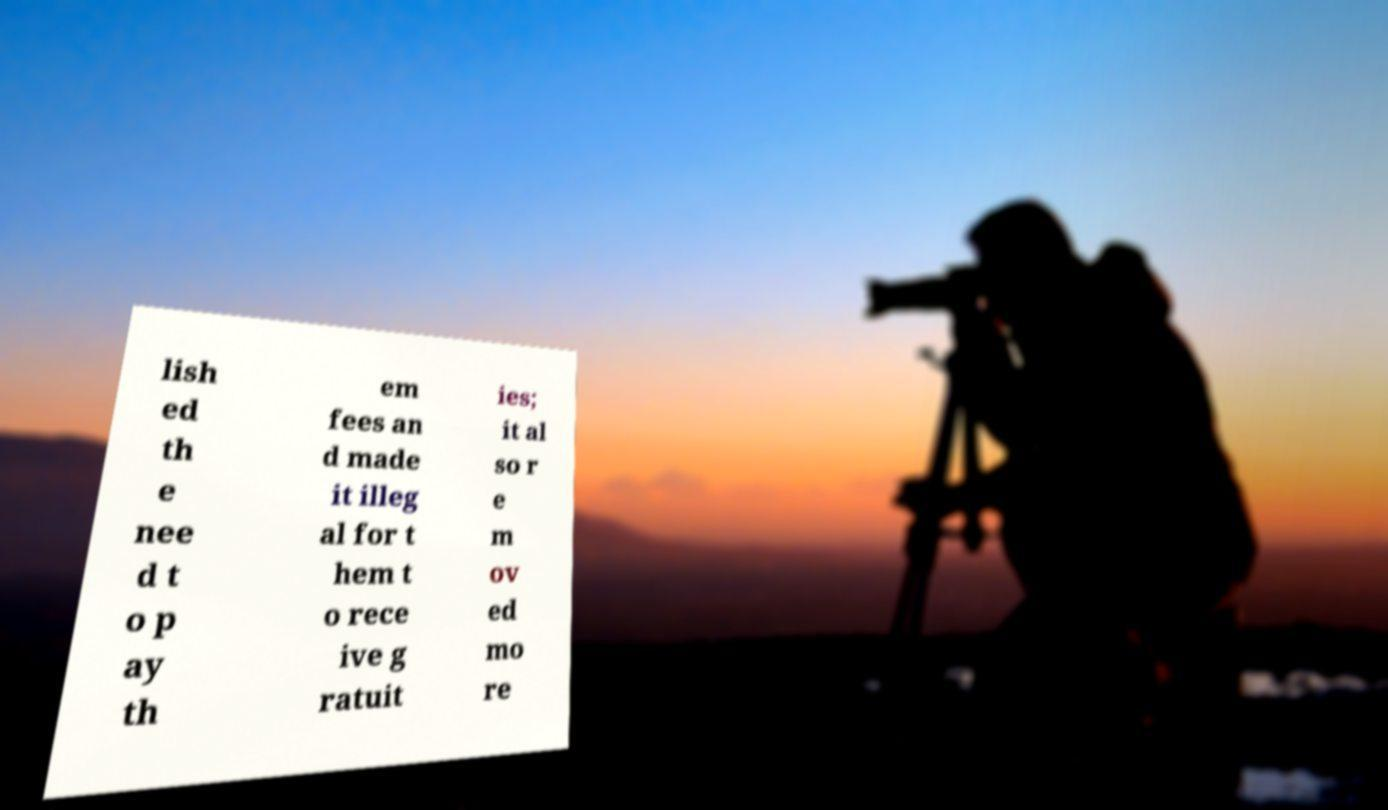Could you extract and type out the text from this image? lish ed th e nee d t o p ay th em fees an d made it illeg al for t hem t o rece ive g ratuit ies; it al so r e m ov ed mo re 